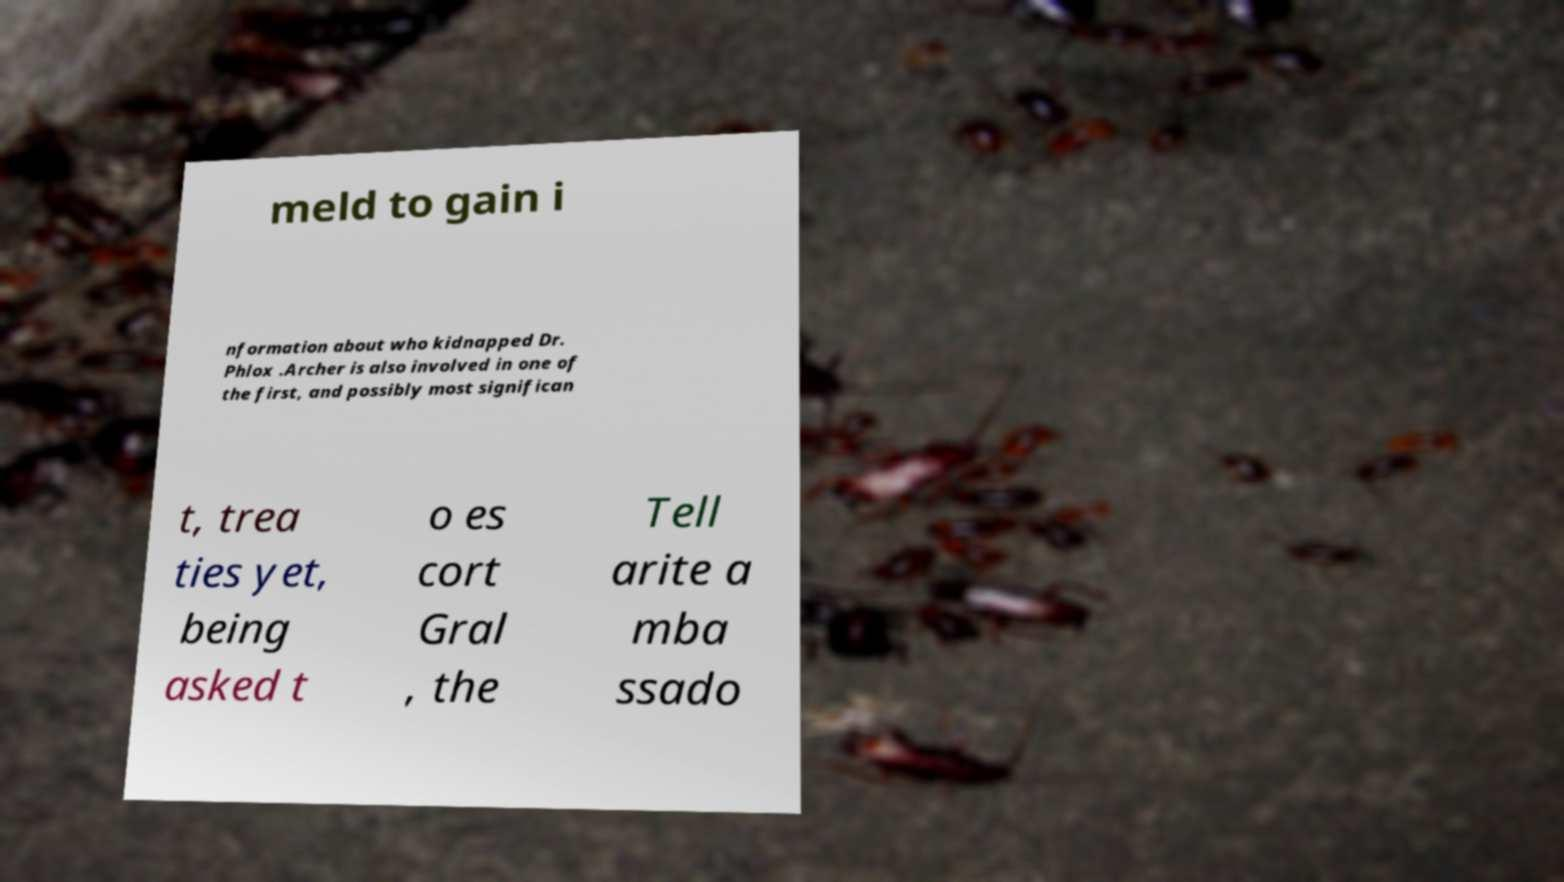For documentation purposes, I need the text within this image transcribed. Could you provide that? meld to gain i nformation about who kidnapped Dr. Phlox .Archer is also involved in one of the first, and possibly most significan t, trea ties yet, being asked t o es cort Gral , the Tell arite a mba ssado 